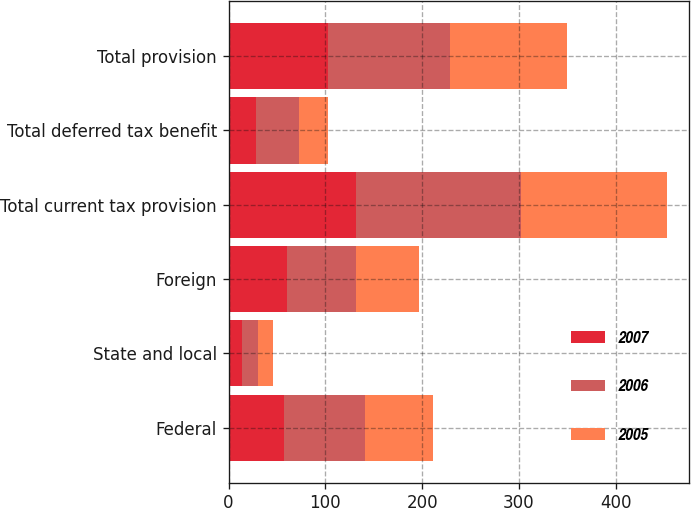Convert chart to OTSL. <chart><loc_0><loc_0><loc_500><loc_500><stacked_bar_chart><ecel><fcel>Federal<fcel>State and local<fcel>Foreign<fcel>Total current tax provision<fcel>Total deferred tax benefit<fcel>Total provision<nl><fcel>2007<fcel>56.8<fcel>14.2<fcel>60.5<fcel>131.5<fcel>28.5<fcel>103<nl><fcel>2006<fcel>83.7<fcel>16<fcel>71<fcel>170.7<fcel>44.7<fcel>126<nl><fcel>2005<fcel>70.3<fcel>15.3<fcel>65<fcel>150.6<fcel>29.8<fcel>120.8<nl></chart> 